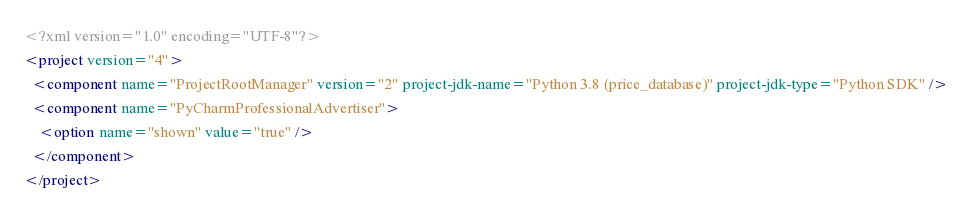Convert code to text. <code><loc_0><loc_0><loc_500><loc_500><_XML_><?xml version="1.0" encoding="UTF-8"?>
<project version="4">
  <component name="ProjectRootManager" version="2" project-jdk-name="Python 3.8 (price_database)" project-jdk-type="Python SDK" />
  <component name="PyCharmProfessionalAdvertiser">
    <option name="shown" value="true" />
  </component>
</project></code> 